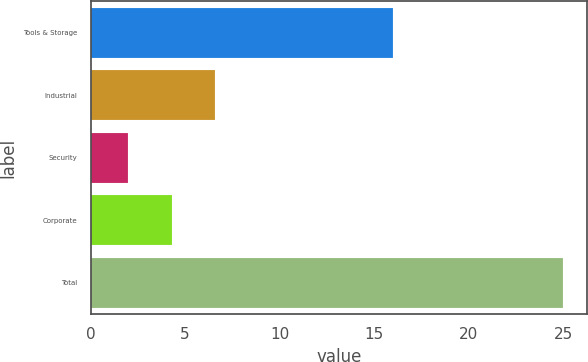Convert chart to OTSL. <chart><loc_0><loc_0><loc_500><loc_500><bar_chart><fcel>Tools & Storage<fcel>Industrial<fcel>Security<fcel>Corporate<fcel>Total<nl><fcel>16<fcel>6.6<fcel>2<fcel>4.3<fcel>25<nl></chart> 